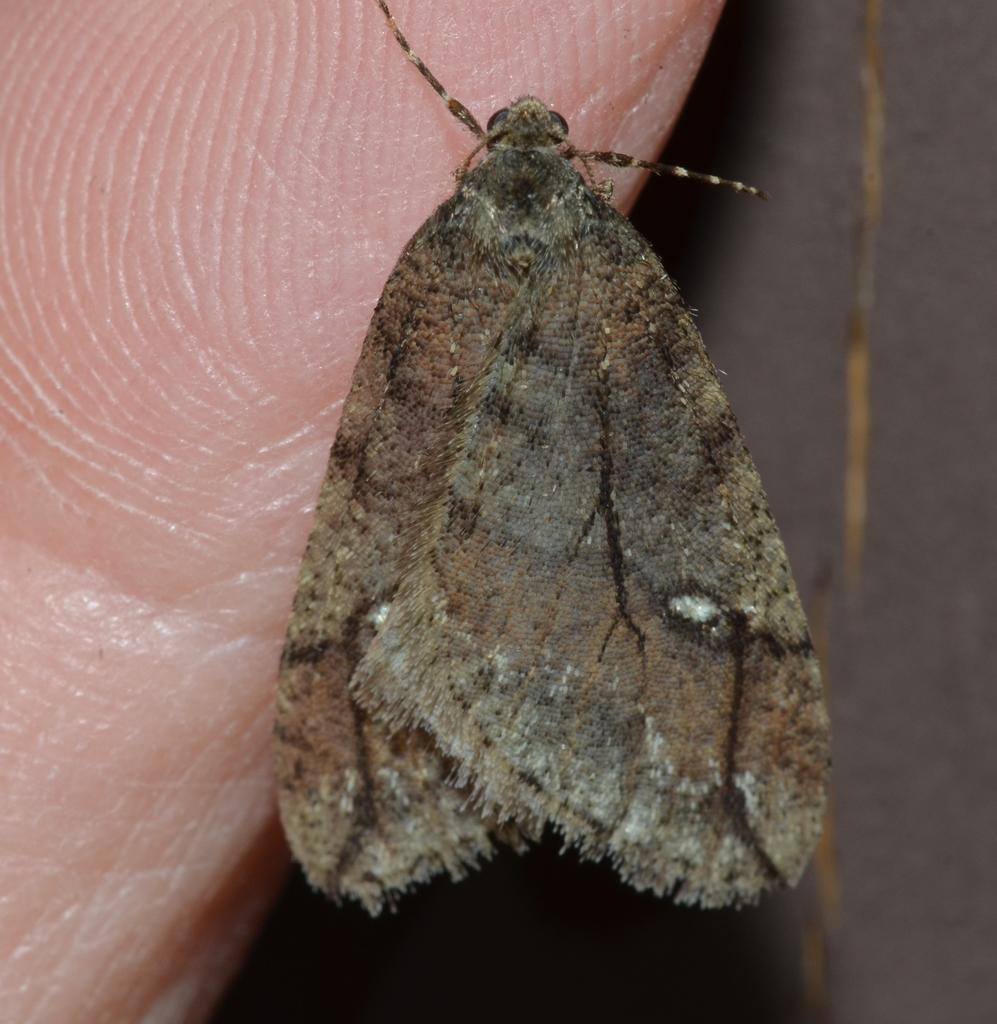What is one of the main features of the image? There is a wall in the image. What type of living organism can be seen in the image? There is an insect in the image. What part of a human body is visible in the image? A human palm is visible in the image. What color is the bird in the image? There is no bird present in the image. What type of stew is being prepared in the image? There is no stew being prepared in the image. 